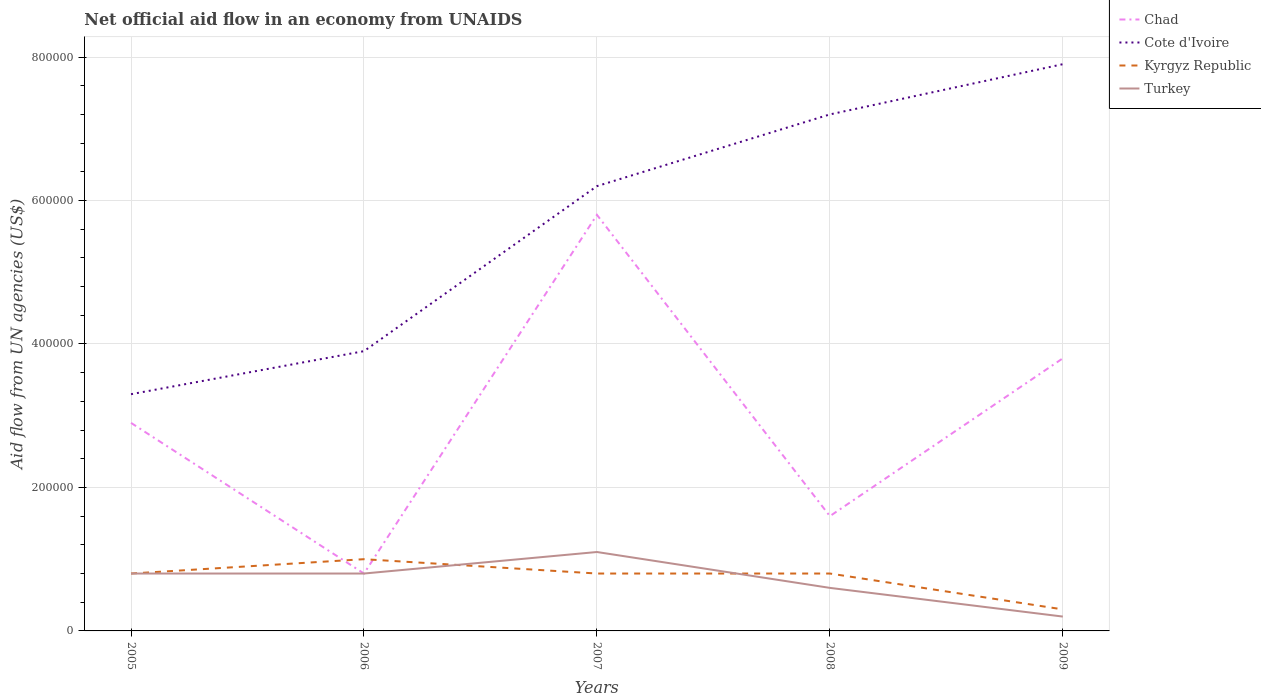Does the line corresponding to Turkey intersect with the line corresponding to Cote d'Ivoire?
Ensure brevity in your answer.  No. Across all years, what is the maximum net official aid flow in Cote d'Ivoire?
Provide a short and direct response. 3.30e+05. In which year was the net official aid flow in Kyrgyz Republic maximum?
Make the answer very short. 2009. What is the total net official aid flow in Cote d'Ivoire in the graph?
Your answer should be very brief. -6.00e+04. What is the difference between the highest and the second highest net official aid flow in Chad?
Offer a very short reply. 5.00e+05. What is the difference between the highest and the lowest net official aid flow in Turkey?
Offer a very short reply. 3. Is the net official aid flow in Turkey strictly greater than the net official aid flow in Chad over the years?
Your answer should be very brief. No. How are the legend labels stacked?
Provide a succinct answer. Vertical. What is the title of the graph?
Keep it short and to the point. Net official aid flow in an economy from UNAIDS. Does "India" appear as one of the legend labels in the graph?
Offer a terse response. No. What is the label or title of the X-axis?
Your response must be concise. Years. What is the label or title of the Y-axis?
Your answer should be compact. Aid flow from UN agencies (US$). What is the Aid flow from UN agencies (US$) in Cote d'Ivoire in 2005?
Make the answer very short. 3.30e+05. What is the Aid flow from UN agencies (US$) in Turkey in 2005?
Ensure brevity in your answer.  8.00e+04. What is the Aid flow from UN agencies (US$) of Cote d'Ivoire in 2006?
Ensure brevity in your answer.  3.90e+05. What is the Aid flow from UN agencies (US$) in Chad in 2007?
Ensure brevity in your answer.  5.80e+05. What is the Aid flow from UN agencies (US$) in Cote d'Ivoire in 2007?
Offer a very short reply. 6.20e+05. What is the Aid flow from UN agencies (US$) of Turkey in 2007?
Your answer should be compact. 1.10e+05. What is the Aid flow from UN agencies (US$) of Chad in 2008?
Keep it short and to the point. 1.60e+05. What is the Aid flow from UN agencies (US$) of Cote d'Ivoire in 2008?
Make the answer very short. 7.20e+05. What is the Aid flow from UN agencies (US$) in Turkey in 2008?
Offer a very short reply. 6.00e+04. What is the Aid flow from UN agencies (US$) in Cote d'Ivoire in 2009?
Offer a very short reply. 7.90e+05. Across all years, what is the maximum Aid flow from UN agencies (US$) of Chad?
Give a very brief answer. 5.80e+05. Across all years, what is the maximum Aid flow from UN agencies (US$) in Cote d'Ivoire?
Provide a succinct answer. 7.90e+05. Across all years, what is the minimum Aid flow from UN agencies (US$) in Cote d'Ivoire?
Offer a very short reply. 3.30e+05. Across all years, what is the minimum Aid flow from UN agencies (US$) in Kyrgyz Republic?
Your response must be concise. 3.00e+04. Across all years, what is the minimum Aid flow from UN agencies (US$) of Turkey?
Ensure brevity in your answer.  2.00e+04. What is the total Aid flow from UN agencies (US$) in Chad in the graph?
Ensure brevity in your answer.  1.49e+06. What is the total Aid flow from UN agencies (US$) of Cote d'Ivoire in the graph?
Provide a short and direct response. 2.85e+06. What is the difference between the Aid flow from UN agencies (US$) in Cote d'Ivoire in 2005 and that in 2006?
Your answer should be very brief. -6.00e+04. What is the difference between the Aid flow from UN agencies (US$) of Chad in 2005 and that in 2007?
Provide a short and direct response. -2.90e+05. What is the difference between the Aid flow from UN agencies (US$) of Kyrgyz Republic in 2005 and that in 2007?
Your response must be concise. 0. What is the difference between the Aid flow from UN agencies (US$) in Cote d'Ivoire in 2005 and that in 2008?
Your answer should be very brief. -3.90e+05. What is the difference between the Aid flow from UN agencies (US$) in Kyrgyz Republic in 2005 and that in 2008?
Make the answer very short. 0. What is the difference between the Aid flow from UN agencies (US$) of Turkey in 2005 and that in 2008?
Offer a terse response. 2.00e+04. What is the difference between the Aid flow from UN agencies (US$) in Chad in 2005 and that in 2009?
Provide a succinct answer. -9.00e+04. What is the difference between the Aid flow from UN agencies (US$) in Cote d'Ivoire in 2005 and that in 2009?
Provide a succinct answer. -4.60e+05. What is the difference between the Aid flow from UN agencies (US$) in Chad in 2006 and that in 2007?
Keep it short and to the point. -5.00e+05. What is the difference between the Aid flow from UN agencies (US$) in Cote d'Ivoire in 2006 and that in 2007?
Your answer should be very brief. -2.30e+05. What is the difference between the Aid flow from UN agencies (US$) in Turkey in 2006 and that in 2007?
Your answer should be compact. -3.00e+04. What is the difference between the Aid flow from UN agencies (US$) in Chad in 2006 and that in 2008?
Make the answer very short. -8.00e+04. What is the difference between the Aid flow from UN agencies (US$) of Cote d'Ivoire in 2006 and that in 2008?
Your answer should be compact. -3.30e+05. What is the difference between the Aid flow from UN agencies (US$) in Turkey in 2006 and that in 2008?
Your answer should be compact. 2.00e+04. What is the difference between the Aid flow from UN agencies (US$) of Cote d'Ivoire in 2006 and that in 2009?
Your answer should be compact. -4.00e+05. What is the difference between the Aid flow from UN agencies (US$) of Turkey in 2007 and that in 2008?
Your answer should be very brief. 5.00e+04. What is the difference between the Aid flow from UN agencies (US$) of Chad in 2007 and that in 2009?
Provide a short and direct response. 2.00e+05. What is the difference between the Aid flow from UN agencies (US$) in Turkey in 2007 and that in 2009?
Your response must be concise. 9.00e+04. What is the difference between the Aid flow from UN agencies (US$) in Chad in 2008 and that in 2009?
Make the answer very short. -2.20e+05. What is the difference between the Aid flow from UN agencies (US$) in Cote d'Ivoire in 2008 and that in 2009?
Provide a succinct answer. -7.00e+04. What is the difference between the Aid flow from UN agencies (US$) of Kyrgyz Republic in 2008 and that in 2009?
Keep it short and to the point. 5.00e+04. What is the difference between the Aid flow from UN agencies (US$) of Turkey in 2008 and that in 2009?
Your response must be concise. 4.00e+04. What is the difference between the Aid flow from UN agencies (US$) in Chad in 2005 and the Aid flow from UN agencies (US$) in Cote d'Ivoire in 2006?
Keep it short and to the point. -1.00e+05. What is the difference between the Aid flow from UN agencies (US$) in Chad in 2005 and the Aid flow from UN agencies (US$) in Cote d'Ivoire in 2007?
Offer a terse response. -3.30e+05. What is the difference between the Aid flow from UN agencies (US$) of Chad in 2005 and the Aid flow from UN agencies (US$) of Turkey in 2007?
Offer a terse response. 1.80e+05. What is the difference between the Aid flow from UN agencies (US$) of Kyrgyz Republic in 2005 and the Aid flow from UN agencies (US$) of Turkey in 2007?
Offer a very short reply. -3.00e+04. What is the difference between the Aid flow from UN agencies (US$) in Chad in 2005 and the Aid flow from UN agencies (US$) in Cote d'Ivoire in 2008?
Ensure brevity in your answer.  -4.30e+05. What is the difference between the Aid flow from UN agencies (US$) in Kyrgyz Republic in 2005 and the Aid flow from UN agencies (US$) in Turkey in 2008?
Keep it short and to the point. 2.00e+04. What is the difference between the Aid flow from UN agencies (US$) of Chad in 2005 and the Aid flow from UN agencies (US$) of Cote d'Ivoire in 2009?
Give a very brief answer. -5.00e+05. What is the difference between the Aid flow from UN agencies (US$) of Kyrgyz Republic in 2005 and the Aid flow from UN agencies (US$) of Turkey in 2009?
Offer a very short reply. 6.00e+04. What is the difference between the Aid flow from UN agencies (US$) of Chad in 2006 and the Aid flow from UN agencies (US$) of Cote d'Ivoire in 2007?
Provide a succinct answer. -5.40e+05. What is the difference between the Aid flow from UN agencies (US$) in Chad in 2006 and the Aid flow from UN agencies (US$) in Turkey in 2007?
Ensure brevity in your answer.  -3.00e+04. What is the difference between the Aid flow from UN agencies (US$) in Cote d'Ivoire in 2006 and the Aid flow from UN agencies (US$) in Kyrgyz Republic in 2007?
Offer a terse response. 3.10e+05. What is the difference between the Aid flow from UN agencies (US$) of Cote d'Ivoire in 2006 and the Aid flow from UN agencies (US$) of Turkey in 2007?
Provide a short and direct response. 2.80e+05. What is the difference between the Aid flow from UN agencies (US$) of Chad in 2006 and the Aid flow from UN agencies (US$) of Cote d'Ivoire in 2008?
Make the answer very short. -6.40e+05. What is the difference between the Aid flow from UN agencies (US$) of Cote d'Ivoire in 2006 and the Aid flow from UN agencies (US$) of Kyrgyz Republic in 2008?
Provide a short and direct response. 3.10e+05. What is the difference between the Aid flow from UN agencies (US$) of Chad in 2006 and the Aid flow from UN agencies (US$) of Cote d'Ivoire in 2009?
Make the answer very short. -7.10e+05. What is the difference between the Aid flow from UN agencies (US$) in Cote d'Ivoire in 2006 and the Aid flow from UN agencies (US$) in Kyrgyz Republic in 2009?
Keep it short and to the point. 3.60e+05. What is the difference between the Aid flow from UN agencies (US$) of Chad in 2007 and the Aid flow from UN agencies (US$) of Kyrgyz Republic in 2008?
Your answer should be compact. 5.00e+05. What is the difference between the Aid flow from UN agencies (US$) in Chad in 2007 and the Aid flow from UN agencies (US$) in Turkey in 2008?
Your answer should be compact. 5.20e+05. What is the difference between the Aid flow from UN agencies (US$) in Cote d'Ivoire in 2007 and the Aid flow from UN agencies (US$) in Kyrgyz Republic in 2008?
Provide a succinct answer. 5.40e+05. What is the difference between the Aid flow from UN agencies (US$) of Cote d'Ivoire in 2007 and the Aid flow from UN agencies (US$) of Turkey in 2008?
Make the answer very short. 5.60e+05. What is the difference between the Aid flow from UN agencies (US$) of Chad in 2007 and the Aid flow from UN agencies (US$) of Turkey in 2009?
Keep it short and to the point. 5.60e+05. What is the difference between the Aid flow from UN agencies (US$) in Cote d'Ivoire in 2007 and the Aid flow from UN agencies (US$) in Kyrgyz Republic in 2009?
Your response must be concise. 5.90e+05. What is the difference between the Aid flow from UN agencies (US$) of Cote d'Ivoire in 2007 and the Aid flow from UN agencies (US$) of Turkey in 2009?
Ensure brevity in your answer.  6.00e+05. What is the difference between the Aid flow from UN agencies (US$) of Chad in 2008 and the Aid flow from UN agencies (US$) of Cote d'Ivoire in 2009?
Your answer should be very brief. -6.30e+05. What is the difference between the Aid flow from UN agencies (US$) in Chad in 2008 and the Aid flow from UN agencies (US$) in Kyrgyz Republic in 2009?
Your answer should be compact. 1.30e+05. What is the difference between the Aid flow from UN agencies (US$) in Chad in 2008 and the Aid flow from UN agencies (US$) in Turkey in 2009?
Your response must be concise. 1.40e+05. What is the difference between the Aid flow from UN agencies (US$) in Cote d'Ivoire in 2008 and the Aid flow from UN agencies (US$) in Kyrgyz Republic in 2009?
Keep it short and to the point. 6.90e+05. What is the difference between the Aid flow from UN agencies (US$) of Cote d'Ivoire in 2008 and the Aid flow from UN agencies (US$) of Turkey in 2009?
Offer a very short reply. 7.00e+05. What is the difference between the Aid flow from UN agencies (US$) of Kyrgyz Republic in 2008 and the Aid flow from UN agencies (US$) of Turkey in 2009?
Ensure brevity in your answer.  6.00e+04. What is the average Aid flow from UN agencies (US$) of Chad per year?
Ensure brevity in your answer.  2.98e+05. What is the average Aid flow from UN agencies (US$) of Cote d'Ivoire per year?
Your answer should be compact. 5.70e+05. What is the average Aid flow from UN agencies (US$) in Kyrgyz Republic per year?
Keep it short and to the point. 7.40e+04. In the year 2005, what is the difference between the Aid flow from UN agencies (US$) in Chad and Aid flow from UN agencies (US$) in Kyrgyz Republic?
Provide a succinct answer. 2.10e+05. In the year 2005, what is the difference between the Aid flow from UN agencies (US$) in Chad and Aid flow from UN agencies (US$) in Turkey?
Provide a succinct answer. 2.10e+05. In the year 2006, what is the difference between the Aid flow from UN agencies (US$) in Chad and Aid flow from UN agencies (US$) in Cote d'Ivoire?
Your answer should be compact. -3.10e+05. In the year 2006, what is the difference between the Aid flow from UN agencies (US$) in Chad and Aid flow from UN agencies (US$) in Turkey?
Give a very brief answer. 0. In the year 2007, what is the difference between the Aid flow from UN agencies (US$) in Chad and Aid flow from UN agencies (US$) in Cote d'Ivoire?
Ensure brevity in your answer.  -4.00e+04. In the year 2007, what is the difference between the Aid flow from UN agencies (US$) of Chad and Aid flow from UN agencies (US$) of Kyrgyz Republic?
Ensure brevity in your answer.  5.00e+05. In the year 2007, what is the difference between the Aid flow from UN agencies (US$) of Chad and Aid flow from UN agencies (US$) of Turkey?
Provide a succinct answer. 4.70e+05. In the year 2007, what is the difference between the Aid flow from UN agencies (US$) of Cote d'Ivoire and Aid flow from UN agencies (US$) of Kyrgyz Republic?
Make the answer very short. 5.40e+05. In the year 2007, what is the difference between the Aid flow from UN agencies (US$) in Cote d'Ivoire and Aid flow from UN agencies (US$) in Turkey?
Give a very brief answer. 5.10e+05. In the year 2008, what is the difference between the Aid flow from UN agencies (US$) in Chad and Aid flow from UN agencies (US$) in Cote d'Ivoire?
Offer a very short reply. -5.60e+05. In the year 2008, what is the difference between the Aid flow from UN agencies (US$) of Chad and Aid flow from UN agencies (US$) of Kyrgyz Republic?
Offer a very short reply. 8.00e+04. In the year 2008, what is the difference between the Aid flow from UN agencies (US$) of Chad and Aid flow from UN agencies (US$) of Turkey?
Provide a short and direct response. 1.00e+05. In the year 2008, what is the difference between the Aid flow from UN agencies (US$) of Cote d'Ivoire and Aid flow from UN agencies (US$) of Kyrgyz Republic?
Provide a succinct answer. 6.40e+05. In the year 2008, what is the difference between the Aid flow from UN agencies (US$) in Cote d'Ivoire and Aid flow from UN agencies (US$) in Turkey?
Give a very brief answer. 6.60e+05. In the year 2009, what is the difference between the Aid flow from UN agencies (US$) in Chad and Aid flow from UN agencies (US$) in Cote d'Ivoire?
Offer a very short reply. -4.10e+05. In the year 2009, what is the difference between the Aid flow from UN agencies (US$) of Chad and Aid flow from UN agencies (US$) of Turkey?
Give a very brief answer. 3.60e+05. In the year 2009, what is the difference between the Aid flow from UN agencies (US$) in Cote d'Ivoire and Aid flow from UN agencies (US$) in Kyrgyz Republic?
Make the answer very short. 7.60e+05. In the year 2009, what is the difference between the Aid flow from UN agencies (US$) in Cote d'Ivoire and Aid flow from UN agencies (US$) in Turkey?
Give a very brief answer. 7.70e+05. What is the ratio of the Aid flow from UN agencies (US$) of Chad in 2005 to that in 2006?
Offer a very short reply. 3.62. What is the ratio of the Aid flow from UN agencies (US$) of Cote d'Ivoire in 2005 to that in 2006?
Your answer should be compact. 0.85. What is the ratio of the Aid flow from UN agencies (US$) in Cote d'Ivoire in 2005 to that in 2007?
Ensure brevity in your answer.  0.53. What is the ratio of the Aid flow from UN agencies (US$) of Kyrgyz Republic in 2005 to that in 2007?
Your answer should be compact. 1. What is the ratio of the Aid flow from UN agencies (US$) in Turkey in 2005 to that in 2007?
Your response must be concise. 0.73. What is the ratio of the Aid flow from UN agencies (US$) in Chad in 2005 to that in 2008?
Provide a succinct answer. 1.81. What is the ratio of the Aid flow from UN agencies (US$) of Cote d'Ivoire in 2005 to that in 2008?
Give a very brief answer. 0.46. What is the ratio of the Aid flow from UN agencies (US$) of Chad in 2005 to that in 2009?
Offer a very short reply. 0.76. What is the ratio of the Aid flow from UN agencies (US$) of Cote d'Ivoire in 2005 to that in 2009?
Ensure brevity in your answer.  0.42. What is the ratio of the Aid flow from UN agencies (US$) of Kyrgyz Republic in 2005 to that in 2009?
Ensure brevity in your answer.  2.67. What is the ratio of the Aid flow from UN agencies (US$) in Turkey in 2005 to that in 2009?
Your answer should be compact. 4. What is the ratio of the Aid flow from UN agencies (US$) of Chad in 2006 to that in 2007?
Offer a terse response. 0.14. What is the ratio of the Aid flow from UN agencies (US$) in Cote d'Ivoire in 2006 to that in 2007?
Offer a very short reply. 0.63. What is the ratio of the Aid flow from UN agencies (US$) of Turkey in 2006 to that in 2007?
Offer a very short reply. 0.73. What is the ratio of the Aid flow from UN agencies (US$) of Cote d'Ivoire in 2006 to that in 2008?
Provide a succinct answer. 0.54. What is the ratio of the Aid flow from UN agencies (US$) of Kyrgyz Republic in 2006 to that in 2008?
Give a very brief answer. 1.25. What is the ratio of the Aid flow from UN agencies (US$) in Turkey in 2006 to that in 2008?
Offer a very short reply. 1.33. What is the ratio of the Aid flow from UN agencies (US$) in Chad in 2006 to that in 2009?
Make the answer very short. 0.21. What is the ratio of the Aid flow from UN agencies (US$) in Cote d'Ivoire in 2006 to that in 2009?
Your response must be concise. 0.49. What is the ratio of the Aid flow from UN agencies (US$) of Chad in 2007 to that in 2008?
Offer a very short reply. 3.62. What is the ratio of the Aid flow from UN agencies (US$) of Cote d'Ivoire in 2007 to that in 2008?
Make the answer very short. 0.86. What is the ratio of the Aid flow from UN agencies (US$) of Turkey in 2007 to that in 2008?
Offer a terse response. 1.83. What is the ratio of the Aid flow from UN agencies (US$) in Chad in 2007 to that in 2009?
Provide a succinct answer. 1.53. What is the ratio of the Aid flow from UN agencies (US$) of Cote d'Ivoire in 2007 to that in 2009?
Your answer should be very brief. 0.78. What is the ratio of the Aid flow from UN agencies (US$) of Kyrgyz Republic in 2007 to that in 2009?
Offer a terse response. 2.67. What is the ratio of the Aid flow from UN agencies (US$) in Turkey in 2007 to that in 2009?
Keep it short and to the point. 5.5. What is the ratio of the Aid flow from UN agencies (US$) in Chad in 2008 to that in 2009?
Provide a short and direct response. 0.42. What is the ratio of the Aid flow from UN agencies (US$) in Cote d'Ivoire in 2008 to that in 2009?
Keep it short and to the point. 0.91. What is the ratio of the Aid flow from UN agencies (US$) in Kyrgyz Republic in 2008 to that in 2009?
Your answer should be very brief. 2.67. What is the ratio of the Aid flow from UN agencies (US$) in Turkey in 2008 to that in 2009?
Offer a terse response. 3. What is the difference between the highest and the second highest Aid flow from UN agencies (US$) in Chad?
Provide a succinct answer. 2.00e+05. What is the difference between the highest and the second highest Aid flow from UN agencies (US$) of Cote d'Ivoire?
Ensure brevity in your answer.  7.00e+04. What is the difference between the highest and the second highest Aid flow from UN agencies (US$) in Kyrgyz Republic?
Your response must be concise. 2.00e+04. What is the difference between the highest and the lowest Aid flow from UN agencies (US$) in Cote d'Ivoire?
Ensure brevity in your answer.  4.60e+05. What is the difference between the highest and the lowest Aid flow from UN agencies (US$) in Kyrgyz Republic?
Your response must be concise. 7.00e+04. What is the difference between the highest and the lowest Aid flow from UN agencies (US$) in Turkey?
Your answer should be compact. 9.00e+04. 